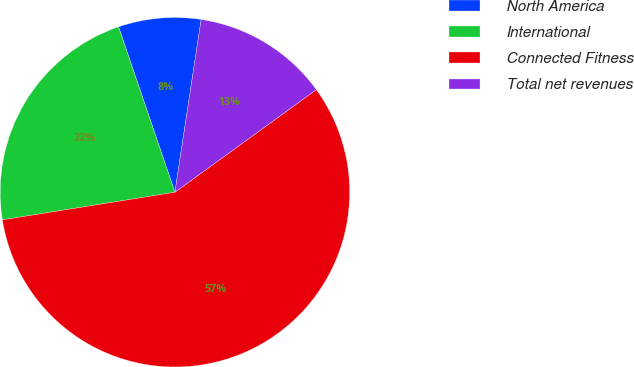Convert chart. <chart><loc_0><loc_0><loc_500><loc_500><pie_chart><fcel>North America<fcel>International<fcel>Connected Fitness<fcel>Total net revenues<nl><fcel>7.63%<fcel>22.3%<fcel>57.46%<fcel>12.61%<nl></chart> 